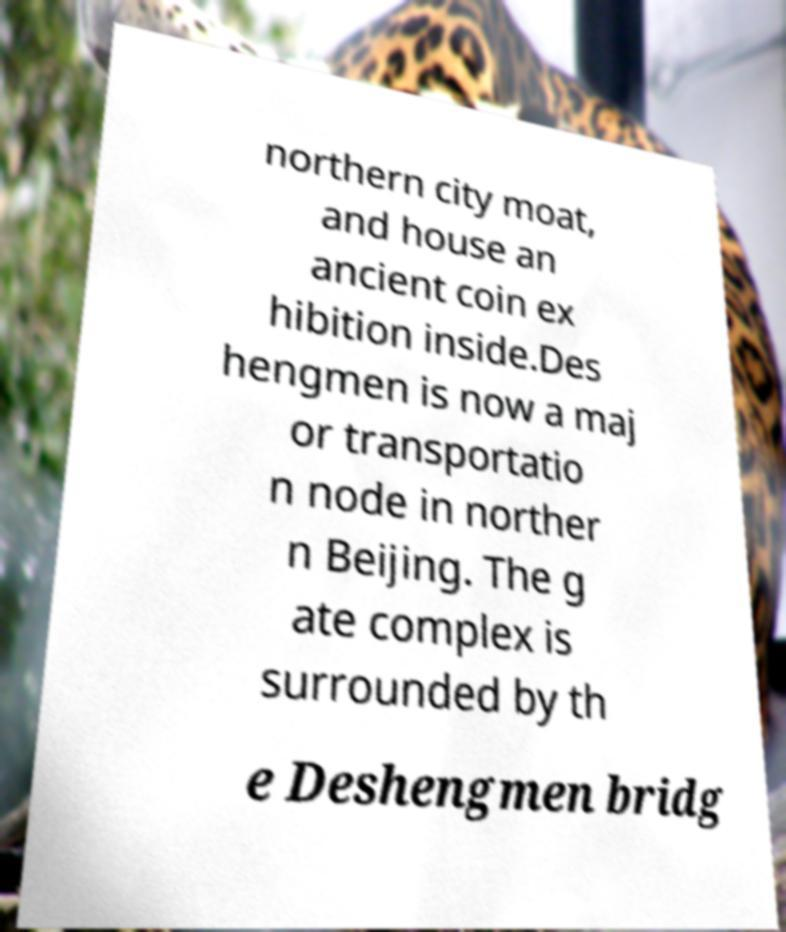Please identify and transcribe the text found in this image. northern city moat, and house an ancient coin ex hibition inside.Des hengmen is now a maj or transportatio n node in norther n Beijing. The g ate complex is surrounded by th e Deshengmen bridg 